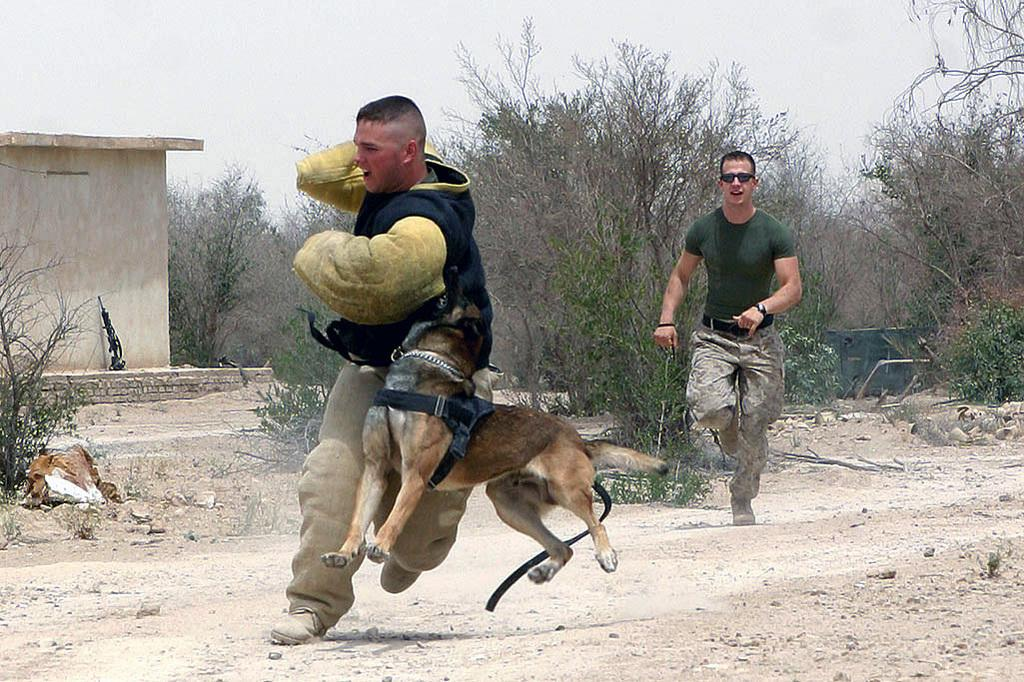How many people are in the image? There are two men in the image. What are the men doing in the image? The men are running. What other living creature is present in the image? There is a dog in the image. What can be seen in the background of the image? There are trees, a small house, and soil visible in the background of the image. What type of egg is being cracked by the finger in the image? There is no egg or finger present in the image. What crime did the men commit that landed them in jail in the image? There is no jail or criminal activity depicted in the image; the men are simply running. 